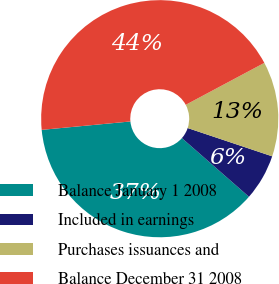<chart> <loc_0><loc_0><loc_500><loc_500><pie_chart><fcel>Balance January 1 2008<fcel>Included in earnings<fcel>Purchases issuances and<fcel>Balance December 31 2008<nl><fcel>37.06%<fcel>6.3%<fcel>12.94%<fcel>43.7%<nl></chart> 